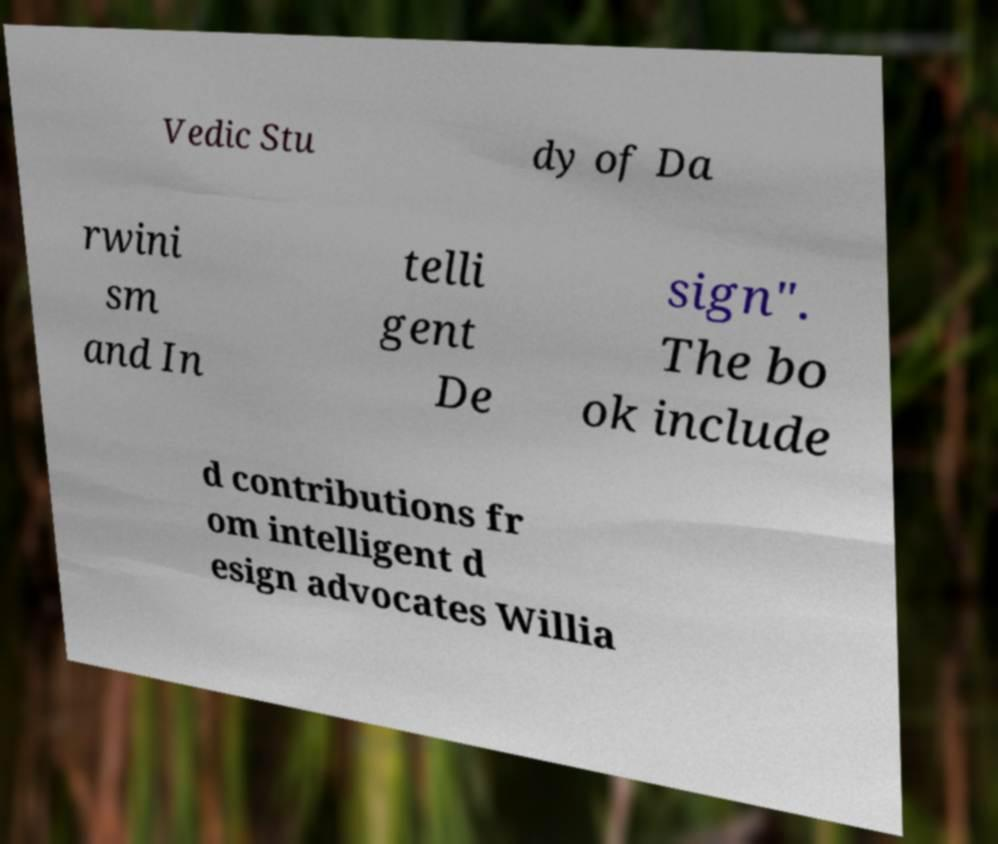Can you read and provide the text displayed in the image?This photo seems to have some interesting text. Can you extract and type it out for me? Vedic Stu dy of Da rwini sm and In telli gent De sign". The bo ok include d contributions fr om intelligent d esign advocates Willia 